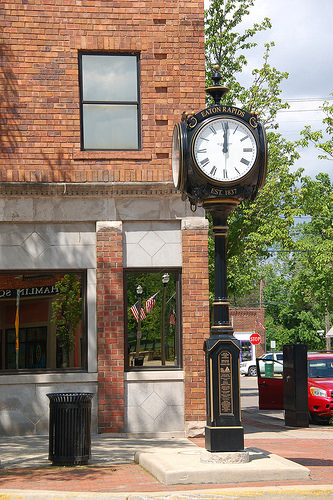<image>
Is there a car door behind the electrical box? Yes. From this viewpoint, the car door is positioned behind the electrical box, with the electrical box partially or fully occluding the car door. 